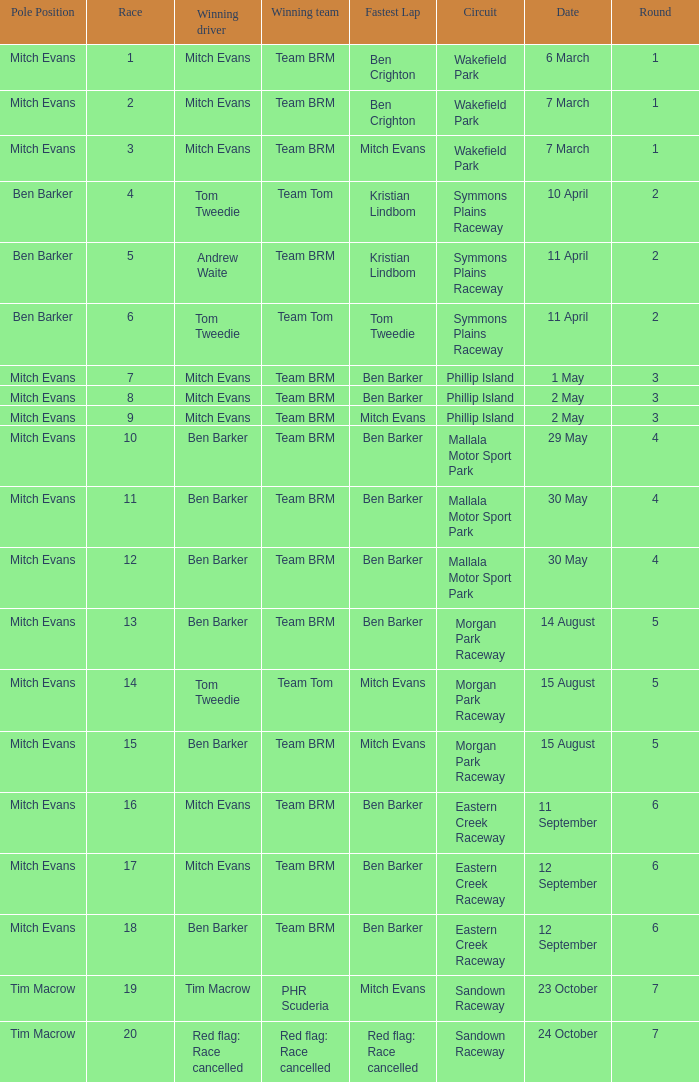In how many rounds was Race 17? 1.0. 